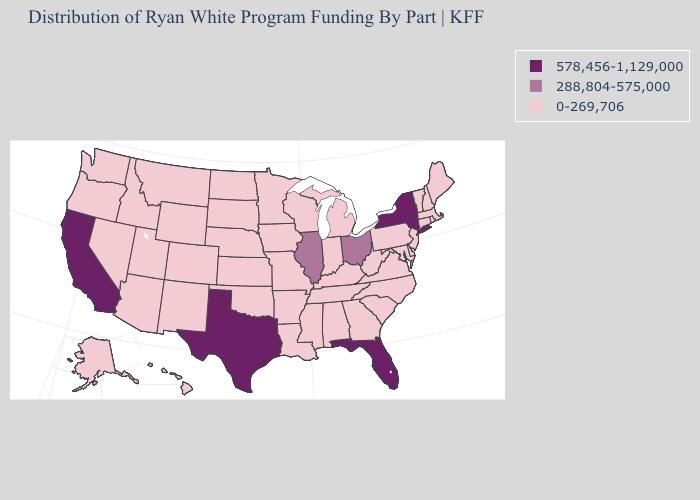Among the states that border Rhode Island , which have the lowest value?
Keep it brief. Connecticut, Massachusetts. Name the states that have a value in the range 288,804-575,000?
Be succinct. Illinois, Ohio. Is the legend a continuous bar?
Short answer required. No. What is the value of Arizona?
Keep it brief. 0-269,706. Name the states that have a value in the range 0-269,706?
Short answer required. Alabama, Alaska, Arizona, Arkansas, Colorado, Connecticut, Delaware, Georgia, Hawaii, Idaho, Indiana, Iowa, Kansas, Kentucky, Louisiana, Maine, Maryland, Massachusetts, Michigan, Minnesota, Mississippi, Missouri, Montana, Nebraska, Nevada, New Hampshire, New Jersey, New Mexico, North Carolina, North Dakota, Oklahoma, Oregon, Pennsylvania, Rhode Island, South Carolina, South Dakota, Tennessee, Utah, Vermont, Virginia, Washington, West Virginia, Wisconsin, Wyoming. What is the lowest value in the USA?
Be succinct. 0-269,706. What is the lowest value in the USA?
Answer briefly. 0-269,706. Name the states that have a value in the range 0-269,706?
Concise answer only. Alabama, Alaska, Arizona, Arkansas, Colorado, Connecticut, Delaware, Georgia, Hawaii, Idaho, Indiana, Iowa, Kansas, Kentucky, Louisiana, Maine, Maryland, Massachusetts, Michigan, Minnesota, Mississippi, Missouri, Montana, Nebraska, Nevada, New Hampshire, New Jersey, New Mexico, North Carolina, North Dakota, Oklahoma, Oregon, Pennsylvania, Rhode Island, South Carolina, South Dakota, Tennessee, Utah, Vermont, Virginia, Washington, West Virginia, Wisconsin, Wyoming. What is the value of Louisiana?
Quick response, please. 0-269,706. What is the highest value in states that border Louisiana?
Keep it brief. 578,456-1,129,000. What is the value of Texas?
Answer briefly. 578,456-1,129,000. What is the value of Delaware?
Be succinct. 0-269,706. What is the lowest value in the USA?
Give a very brief answer. 0-269,706. Name the states that have a value in the range 288,804-575,000?
Quick response, please. Illinois, Ohio. 